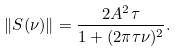<formula> <loc_0><loc_0><loc_500><loc_500>\| S ( \nu ) \| = \frac { 2 A ^ { 2 } \tau } { 1 + ( 2 \pi \tau \nu ) ^ { 2 } } .</formula> 